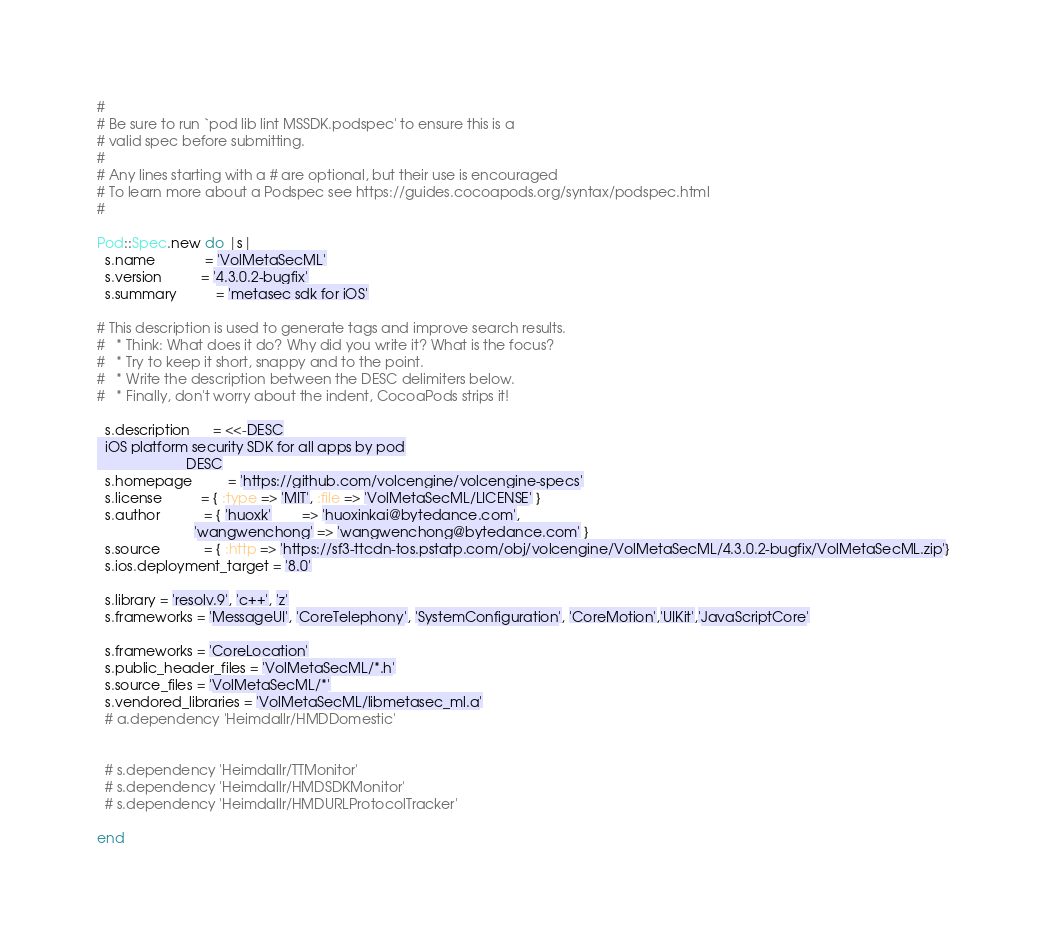<code> <loc_0><loc_0><loc_500><loc_500><_Ruby_>#
# Be sure to run `pod lib lint MSSDK.podspec' to ensure this is a
# valid spec before submitting.
#
# Any lines starting with a # are optional, but their use is encouraged
# To learn more about a Podspec see https://guides.cocoapods.org/syntax/podspec.html
#

Pod::Spec.new do |s|
  s.name             = 'VolMetaSecML'
  s.version          = '4.3.0.2-bugfix'
  s.summary          = 'metasec sdk for iOS'

# This description is used to generate tags and improve search results.
#   * Think: What does it do? Why did you write it? What is the focus?
#   * Try to keep it short, snappy and to the point.
#   * Write the description between the DESC delimiters below.
#   * Finally, don't worry about the indent, CocoaPods strips it!

  s.description      = <<-DESC
  iOS platform security SDK for all apps by pod
                       DESC
  s.homepage         = 'https://github.com/volcengine/volcengine-specs'
  s.license          = { :type => 'MIT', :file => 'VolMetaSecML/LICENSE' }
  s.author           = { 'huoxk'        => 'huoxinkai@bytedance.com',
                         'wangwenchong' => 'wangwenchong@bytedance.com' }
  s.source           = { :http => 'https://sf3-ttcdn-tos.pstatp.com/obj/volcengine/VolMetaSecML/4.3.0.2-bugfix/VolMetaSecML.zip'}
  s.ios.deployment_target = '8.0'

  s.library = 'resolv.9', 'c++', 'z'
  s.frameworks = 'MessageUI', 'CoreTelephony', 'SystemConfiguration', 'CoreMotion','UIKit','JavaScriptCore'

  s.frameworks = 'CoreLocation'
  s.public_header_files = 'VolMetaSecML/*.h'
  s.source_files = 'VolMetaSecML/*'
  s.vendored_libraries = 'VolMetaSecML/libmetasec_ml.a'
  # a.dependency 'Heimdallr/HMDDomestic'
  
  
  # s.dependency 'Heimdallr/TTMonitor'
  # s.dependency 'Heimdallr/HMDSDKMonitor'
  # s.dependency 'Heimdallr/HMDURLProtocolTracker'
  
end
</code> 